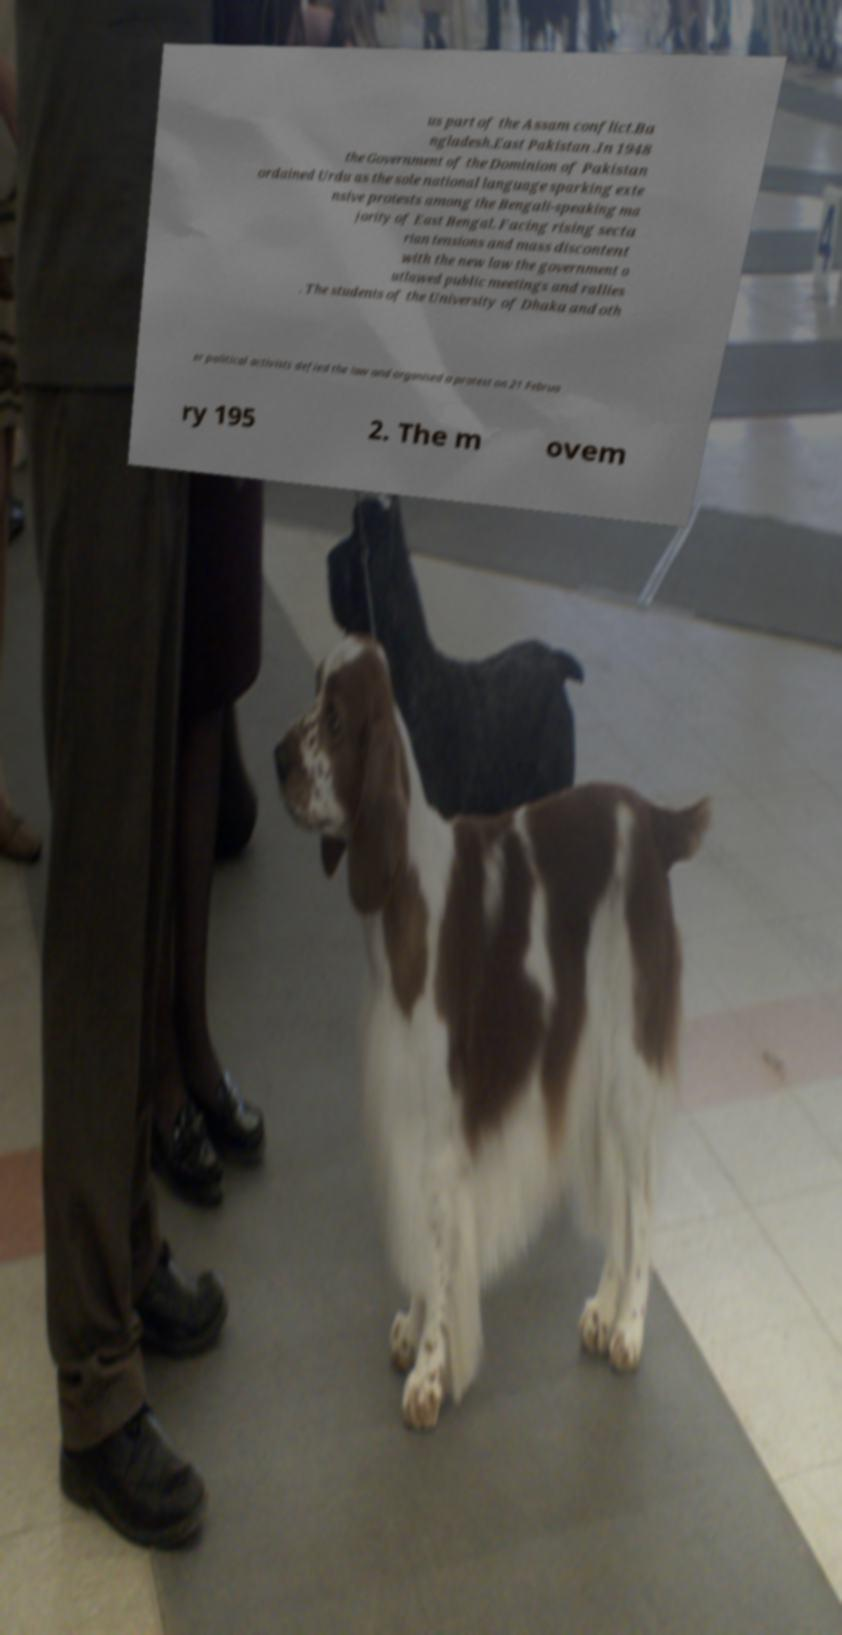Can you accurately transcribe the text from the provided image for me? us part of the Assam conflict.Ba ngladesh.East Pakistan .In 1948 the Government of the Dominion of Pakistan ordained Urdu as the sole national language sparking exte nsive protests among the Bengali-speaking ma jority of East Bengal. Facing rising secta rian tensions and mass discontent with the new law the government o utlawed public meetings and rallies . The students of the University of Dhaka and oth er political activists defied the law and organised a protest on 21 Februa ry 195 2. The m ovem 